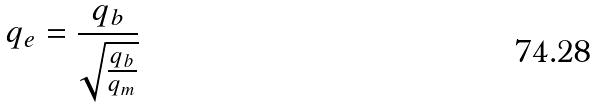<formula> <loc_0><loc_0><loc_500><loc_500>q _ { e } = \frac { q _ { b } } { \sqrt { \frac { q _ { b } } { q _ { m } } } }</formula> 